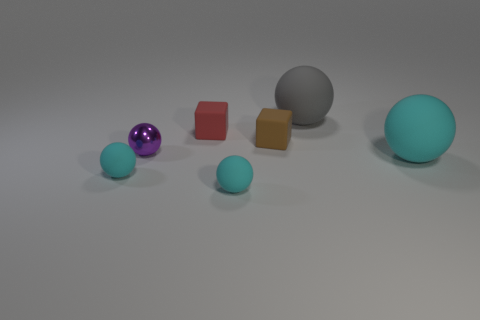How many cyan balls must be subtracted to get 1 cyan balls? 2 Subtract all matte spheres. How many spheres are left? 1 Subtract all gray cylinders. How many cyan spheres are left? 3 Subtract all cyan spheres. How many spheres are left? 2 Add 2 brown cubes. How many objects exist? 9 Subtract 3 spheres. How many spheres are left? 2 Subtract all blocks. How many objects are left? 5 Add 3 big gray matte things. How many big gray matte things are left? 4 Add 3 tiny rubber cubes. How many tiny rubber cubes exist? 5 Subtract 0 cyan cylinders. How many objects are left? 7 